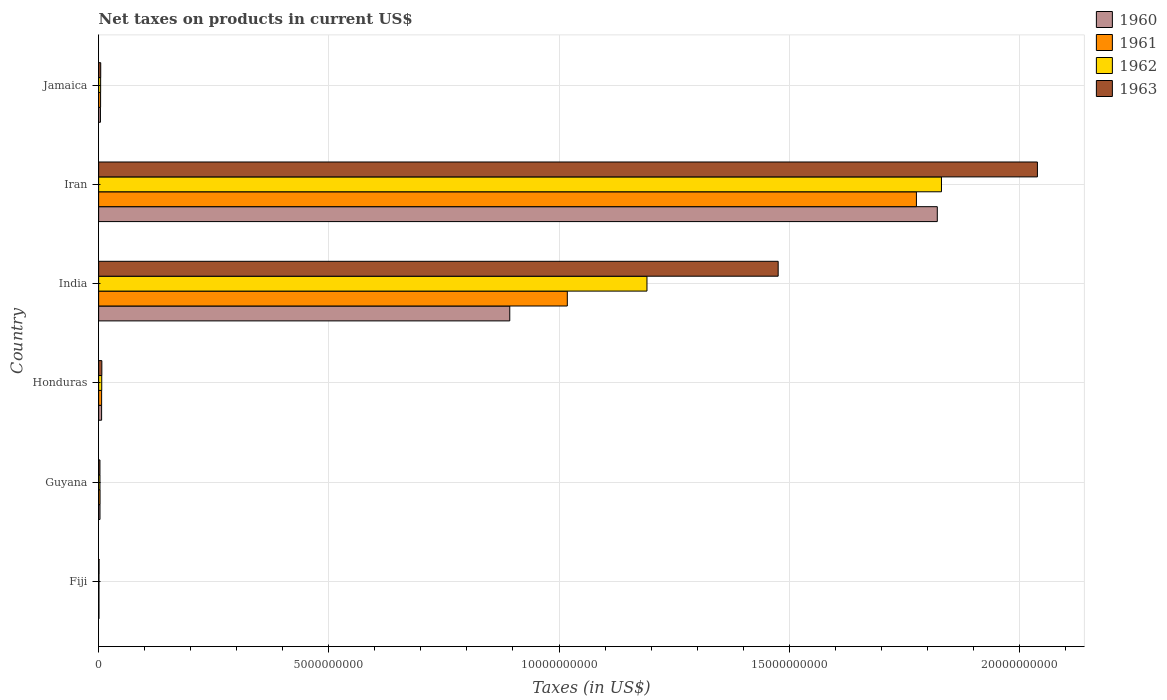How many different coloured bars are there?
Make the answer very short. 4. How many groups of bars are there?
Ensure brevity in your answer.  6. Are the number of bars per tick equal to the number of legend labels?
Offer a very short reply. Yes. What is the label of the 1st group of bars from the top?
Keep it short and to the point. Jamaica. What is the net taxes on products in 1962 in Fiji?
Ensure brevity in your answer.  7.40e+06. Across all countries, what is the maximum net taxes on products in 1963?
Ensure brevity in your answer.  2.04e+1. Across all countries, what is the minimum net taxes on products in 1963?
Provide a succinct answer. 8.90e+06. In which country was the net taxes on products in 1960 maximum?
Make the answer very short. Iran. In which country was the net taxes on products in 1960 minimum?
Offer a very short reply. Fiji. What is the total net taxes on products in 1960 in the graph?
Your response must be concise. 2.73e+1. What is the difference between the net taxes on products in 1961 in Honduras and that in India?
Offer a very short reply. -1.01e+1. What is the difference between the net taxes on products in 1963 in Jamaica and the net taxes on products in 1961 in Honduras?
Keep it short and to the point. -1.96e+07. What is the average net taxes on products in 1962 per country?
Provide a succinct answer. 5.06e+09. What is the difference between the net taxes on products in 1963 and net taxes on products in 1962 in Guyana?
Provide a succinct answer. -8.00e+05. What is the ratio of the net taxes on products in 1963 in Guyana to that in Jamaica?
Your answer should be compact. 0.62. Is the net taxes on products in 1962 in Iran less than that in Jamaica?
Offer a terse response. No. Is the difference between the net taxes on products in 1963 in Fiji and Honduras greater than the difference between the net taxes on products in 1962 in Fiji and Honduras?
Give a very brief answer. No. What is the difference between the highest and the second highest net taxes on products in 1962?
Keep it short and to the point. 6.40e+09. What is the difference between the highest and the lowest net taxes on products in 1963?
Offer a very short reply. 2.04e+1. Is it the case that in every country, the sum of the net taxes on products in 1962 and net taxes on products in 1960 is greater than the sum of net taxes on products in 1963 and net taxes on products in 1961?
Your response must be concise. No. What does the 2nd bar from the top in Guyana represents?
Make the answer very short. 1962. Are all the bars in the graph horizontal?
Your response must be concise. Yes. What is the difference between two consecutive major ticks on the X-axis?
Make the answer very short. 5.00e+09. Does the graph contain any zero values?
Make the answer very short. No. Does the graph contain grids?
Your answer should be very brief. Yes. What is the title of the graph?
Offer a terse response. Net taxes on products in current US$. Does "1964" appear as one of the legend labels in the graph?
Ensure brevity in your answer.  No. What is the label or title of the X-axis?
Provide a short and direct response. Taxes (in US$). What is the label or title of the Y-axis?
Provide a succinct answer. Country. What is the Taxes (in US$) of 1960 in Fiji?
Your answer should be very brief. 6.80e+06. What is the Taxes (in US$) in 1961 in Fiji?
Your response must be concise. 6.80e+06. What is the Taxes (in US$) of 1962 in Fiji?
Your response must be concise. 7.40e+06. What is the Taxes (in US$) in 1963 in Fiji?
Provide a succinct answer. 8.90e+06. What is the Taxes (in US$) in 1960 in Guyana?
Offer a terse response. 2.94e+07. What is the Taxes (in US$) of 1961 in Guyana?
Give a very brief answer. 3.07e+07. What is the Taxes (in US$) in 1962 in Guyana?
Give a very brief answer. 2.90e+07. What is the Taxes (in US$) in 1963 in Guyana?
Offer a terse response. 2.82e+07. What is the Taxes (in US$) in 1960 in Honduras?
Ensure brevity in your answer.  6.45e+07. What is the Taxes (in US$) in 1961 in Honduras?
Your response must be concise. 6.50e+07. What is the Taxes (in US$) of 1962 in Honduras?
Your response must be concise. 6.73e+07. What is the Taxes (in US$) in 1963 in Honduras?
Keep it short and to the point. 6.96e+07. What is the Taxes (in US$) of 1960 in India?
Give a very brief answer. 8.93e+09. What is the Taxes (in US$) in 1961 in India?
Provide a short and direct response. 1.02e+1. What is the Taxes (in US$) in 1962 in India?
Your response must be concise. 1.19e+1. What is the Taxes (in US$) in 1963 in India?
Make the answer very short. 1.48e+1. What is the Taxes (in US$) in 1960 in Iran?
Provide a succinct answer. 1.82e+1. What is the Taxes (in US$) in 1961 in Iran?
Ensure brevity in your answer.  1.78e+1. What is the Taxes (in US$) of 1962 in Iran?
Provide a short and direct response. 1.83e+1. What is the Taxes (in US$) of 1963 in Iran?
Offer a very short reply. 2.04e+1. What is the Taxes (in US$) of 1960 in Jamaica?
Provide a short and direct response. 3.93e+07. What is the Taxes (in US$) in 1961 in Jamaica?
Offer a very short reply. 4.26e+07. What is the Taxes (in US$) of 1962 in Jamaica?
Offer a terse response. 4.35e+07. What is the Taxes (in US$) in 1963 in Jamaica?
Make the answer very short. 4.54e+07. Across all countries, what is the maximum Taxes (in US$) of 1960?
Your answer should be very brief. 1.82e+1. Across all countries, what is the maximum Taxes (in US$) of 1961?
Offer a very short reply. 1.78e+1. Across all countries, what is the maximum Taxes (in US$) in 1962?
Your answer should be compact. 1.83e+1. Across all countries, what is the maximum Taxes (in US$) of 1963?
Your answer should be very brief. 2.04e+1. Across all countries, what is the minimum Taxes (in US$) of 1960?
Your response must be concise. 6.80e+06. Across all countries, what is the minimum Taxes (in US$) of 1961?
Keep it short and to the point. 6.80e+06. Across all countries, what is the minimum Taxes (in US$) in 1962?
Offer a very short reply. 7.40e+06. Across all countries, what is the minimum Taxes (in US$) of 1963?
Give a very brief answer. 8.90e+06. What is the total Taxes (in US$) of 1960 in the graph?
Your answer should be compact. 2.73e+1. What is the total Taxes (in US$) of 1961 in the graph?
Offer a terse response. 2.81e+1. What is the total Taxes (in US$) in 1962 in the graph?
Keep it short and to the point. 3.04e+1. What is the total Taxes (in US$) of 1963 in the graph?
Provide a succinct answer. 3.53e+1. What is the difference between the Taxes (in US$) of 1960 in Fiji and that in Guyana?
Make the answer very short. -2.26e+07. What is the difference between the Taxes (in US$) of 1961 in Fiji and that in Guyana?
Offer a terse response. -2.39e+07. What is the difference between the Taxes (in US$) in 1962 in Fiji and that in Guyana?
Provide a short and direct response. -2.16e+07. What is the difference between the Taxes (in US$) of 1963 in Fiji and that in Guyana?
Ensure brevity in your answer.  -1.93e+07. What is the difference between the Taxes (in US$) in 1960 in Fiji and that in Honduras?
Give a very brief answer. -5.77e+07. What is the difference between the Taxes (in US$) in 1961 in Fiji and that in Honduras?
Provide a short and direct response. -5.82e+07. What is the difference between the Taxes (in US$) in 1962 in Fiji and that in Honduras?
Your answer should be very brief. -5.99e+07. What is the difference between the Taxes (in US$) in 1963 in Fiji and that in Honduras?
Your answer should be very brief. -6.07e+07. What is the difference between the Taxes (in US$) of 1960 in Fiji and that in India?
Make the answer very short. -8.92e+09. What is the difference between the Taxes (in US$) of 1961 in Fiji and that in India?
Your response must be concise. -1.02e+1. What is the difference between the Taxes (in US$) in 1962 in Fiji and that in India?
Your answer should be very brief. -1.19e+1. What is the difference between the Taxes (in US$) of 1963 in Fiji and that in India?
Ensure brevity in your answer.  -1.48e+1. What is the difference between the Taxes (in US$) in 1960 in Fiji and that in Iran?
Your answer should be compact. -1.82e+1. What is the difference between the Taxes (in US$) in 1961 in Fiji and that in Iran?
Make the answer very short. -1.78e+1. What is the difference between the Taxes (in US$) in 1962 in Fiji and that in Iran?
Your response must be concise. -1.83e+1. What is the difference between the Taxes (in US$) in 1963 in Fiji and that in Iran?
Your answer should be compact. -2.04e+1. What is the difference between the Taxes (in US$) of 1960 in Fiji and that in Jamaica?
Make the answer very short. -3.25e+07. What is the difference between the Taxes (in US$) of 1961 in Fiji and that in Jamaica?
Make the answer very short. -3.58e+07. What is the difference between the Taxes (in US$) of 1962 in Fiji and that in Jamaica?
Offer a very short reply. -3.61e+07. What is the difference between the Taxes (in US$) of 1963 in Fiji and that in Jamaica?
Provide a short and direct response. -3.65e+07. What is the difference between the Taxes (in US$) of 1960 in Guyana and that in Honduras?
Provide a succinct answer. -3.51e+07. What is the difference between the Taxes (in US$) of 1961 in Guyana and that in Honduras?
Offer a terse response. -3.43e+07. What is the difference between the Taxes (in US$) of 1962 in Guyana and that in Honduras?
Offer a terse response. -3.83e+07. What is the difference between the Taxes (in US$) in 1963 in Guyana and that in Honduras?
Your answer should be compact. -4.14e+07. What is the difference between the Taxes (in US$) of 1960 in Guyana and that in India?
Offer a terse response. -8.90e+09. What is the difference between the Taxes (in US$) in 1961 in Guyana and that in India?
Keep it short and to the point. -1.01e+1. What is the difference between the Taxes (in US$) of 1962 in Guyana and that in India?
Give a very brief answer. -1.19e+1. What is the difference between the Taxes (in US$) of 1963 in Guyana and that in India?
Ensure brevity in your answer.  -1.47e+1. What is the difference between the Taxes (in US$) in 1960 in Guyana and that in Iran?
Offer a terse response. -1.82e+1. What is the difference between the Taxes (in US$) in 1961 in Guyana and that in Iran?
Keep it short and to the point. -1.77e+1. What is the difference between the Taxes (in US$) of 1962 in Guyana and that in Iran?
Offer a terse response. -1.83e+1. What is the difference between the Taxes (in US$) of 1963 in Guyana and that in Iran?
Ensure brevity in your answer.  -2.04e+1. What is the difference between the Taxes (in US$) of 1960 in Guyana and that in Jamaica?
Make the answer very short. -9.90e+06. What is the difference between the Taxes (in US$) of 1961 in Guyana and that in Jamaica?
Your answer should be very brief. -1.19e+07. What is the difference between the Taxes (in US$) of 1962 in Guyana and that in Jamaica?
Provide a short and direct response. -1.45e+07. What is the difference between the Taxes (in US$) in 1963 in Guyana and that in Jamaica?
Give a very brief answer. -1.72e+07. What is the difference between the Taxes (in US$) of 1960 in Honduras and that in India?
Offer a very short reply. -8.87e+09. What is the difference between the Taxes (in US$) in 1961 in Honduras and that in India?
Keep it short and to the point. -1.01e+1. What is the difference between the Taxes (in US$) of 1962 in Honduras and that in India?
Keep it short and to the point. -1.18e+1. What is the difference between the Taxes (in US$) in 1963 in Honduras and that in India?
Your answer should be very brief. -1.47e+1. What is the difference between the Taxes (in US$) of 1960 in Honduras and that in Iran?
Your answer should be compact. -1.82e+1. What is the difference between the Taxes (in US$) of 1961 in Honduras and that in Iran?
Your answer should be compact. -1.77e+1. What is the difference between the Taxes (in US$) of 1962 in Honduras and that in Iran?
Ensure brevity in your answer.  -1.82e+1. What is the difference between the Taxes (in US$) in 1963 in Honduras and that in Iran?
Make the answer very short. -2.03e+1. What is the difference between the Taxes (in US$) of 1960 in Honduras and that in Jamaica?
Provide a succinct answer. 2.52e+07. What is the difference between the Taxes (in US$) in 1961 in Honduras and that in Jamaica?
Offer a terse response. 2.24e+07. What is the difference between the Taxes (in US$) in 1962 in Honduras and that in Jamaica?
Keep it short and to the point. 2.38e+07. What is the difference between the Taxes (in US$) in 1963 in Honduras and that in Jamaica?
Offer a terse response. 2.42e+07. What is the difference between the Taxes (in US$) in 1960 in India and that in Iran?
Your response must be concise. -9.29e+09. What is the difference between the Taxes (in US$) in 1961 in India and that in Iran?
Make the answer very short. -7.58e+09. What is the difference between the Taxes (in US$) of 1962 in India and that in Iran?
Your answer should be very brief. -6.40e+09. What is the difference between the Taxes (in US$) in 1963 in India and that in Iran?
Offer a very short reply. -5.63e+09. What is the difference between the Taxes (in US$) of 1960 in India and that in Jamaica?
Keep it short and to the point. 8.89e+09. What is the difference between the Taxes (in US$) in 1961 in India and that in Jamaica?
Give a very brief answer. 1.01e+1. What is the difference between the Taxes (in US$) of 1962 in India and that in Jamaica?
Ensure brevity in your answer.  1.19e+1. What is the difference between the Taxes (in US$) in 1963 in India and that in Jamaica?
Your answer should be very brief. 1.47e+1. What is the difference between the Taxes (in US$) of 1960 in Iran and that in Jamaica?
Provide a short and direct response. 1.82e+1. What is the difference between the Taxes (in US$) of 1961 in Iran and that in Jamaica?
Keep it short and to the point. 1.77e+1. What is the difference between the Taxes (in US$) in 1962 in Iran and that in Jamaica?
Make the answer very short. 1.83e+1. What is the difference between the Taxes (in US$) in 1963 in Iran and that in Jamaica?
Make the answer very short. 2.03e+1. What is the difference between the Taxes (in US$) in 1960 in Fiji and the Taxes (in US$) in 1961 in Guyana?
Your answer should be compact. -2.39e+07. What is the difference between the Taxes (in US$) in 1960 in Fiji and the Taxes (in US$) in 1962 in Guyana?
Your answer should be compact. -2.22e+07. What is the difference between the Taxes (in US$) of 1960 in Fiji and the Taxes (in US$) of 1963 in Guyana?
Your response must be concise. -2.14e+07. What is the difference between the Taxes (in US$) in 1961 in Fiji and the Taxes (in US$) in 1962 in Guyana?
Make the answer very short. -2.22e+07. What is the difference between the Taxes (in US$) of 1961 in Fiji and the Taxes (in US$) of 1963 in Guyana?
Your answer should be compact. -2.14e+07. What is the difference between the Taxes (in US$) in 1962 in Fiji and the Taxes (in US$) in 1963 in Guyana?
Offer a very short reply. -2.08e+07. What is the difference between the Taxes (in US$) of 1960 in Fiji and the Taxes (in US$) of 1961 in Honduras?
Offer a very short reply. -5.82e+07. What is the difference between the Taxes (in US$) in 1960 in Fiji and the Taxes (in US$) in 1962 in Honduras?
Give a very brief answer. -6.05e+07. What is the difference between the Taxes (in US$) of 1960 in Fiji and the Taxes (in US$) of 1963 in Honduras?
Your answer should be compact. -6.28e+07. What is the difference between the Taxes (in US$) of 1961 in Fiji and the Taxes (in US$) of 1962 in Honduras?
Provide a succinct answer. -6.05e+07. What is the difference between the Taxes (in US$) in 1961 in Fiji and the Taxes (in US$) in 1963 in Honduras?
Offer a terse response. -6.28e+07. What is the difference between the Taxes (in US$) of 1962 in Fiji and the Taxes (in US$) of 1963 in Honduras?
Keep it short and to the point. -6.22e+07. What is the difference between the Taxes (in US$) in 1960 in Fiji and the Taxes (in US$) in 1961 in India?
Your answer should be very brief. -1.02e+1. What is the difference between the Taxes (in US$) of 1960 in Fiji and the Taxes (in US$) of 1962 in India?
Provide a short and direct response. -1.19e+1. What is the difference between the Taxes (in US$) in 1960 in Fiji and the Taxes (in US$) in 1963 in India?
Offer a very short reply. -1.48e+1. What is the difference between the Taxes (in US$) in 1961 in Fiji and the Taxes (in US$) in 1962 in India?
Provide a short and direct response. -1.19e+1. What is the difference between the Taxes (in US$) in 1961 in Fiji and the Taxes (in US$) in 1963 in India?
Provide a succinct answer. -1.48e+1. What is the difference between the Taxes (in US$) of 1962 in Fiji and the Taxes (in US$) of 1963 in India?
Provide a succinct answer. -1.48e+1. What is the difference between the Taxes (in US$) in 1960 in Fiji and the Taxes (in US$) in 1961 in Iran?
Your answer should be compact. -1.78e+1. What is the difference between the Taxes (in US$) of 1960 in Fiji and the Taxes (in US$) of 1962 in Iran?
Give a very brief answer. -1.83e+1. What is the difference between the Taxes (in US$) in 1960 in Fiji and the Taxes (in US$) in 1963 in Iran?
Your response must be concise. -2.04e+1. What is the difference between the Taxes (in US$) in 1961 in Fiji and the Taxes (in US$) in 1962 in Iran?
Keep it short and to the point. -1.83e+1. What is the difference between the Taxes (in US$) of 1961 in Fiji and the Taxes (in US$) of 1963 in Iran?
Give a very brief answer. -2.04e+1. What is the difference between the Taxes (in US$) in 1962 in Fiji and the Taxes (in US$) in 1963 in Iran?
Your answer should be very brief. -2.04e+1. What is the difference between the Taxes (in US$) of 1960 in Fiji and the Taxes (in US$) of 1961 in Jamaica?
Your response must be concise. -3.58e+07. What is the difference between the Taxes (in US$) of 1960 in Fiji and the Taxes (in US$) of 1962 in Jamaica?
Your response must be concise. -3.67e+07. What is the difference between the Taxes (in US$) in 1960 in Fiji and the Taxes (in US$) in 1963 in Jamaica?
Provide a short and direct response. -3.86e+07. What is the difference between the Taxes (in US$) in 1961 in Fiji and the Taxes (in US$) in 1962 in Jamaica?
Provide a short and direct response. -3.67e+07. What is the difference between the Taxes (in US$) in 1961 in Fiji and the Taxes (in US$) in 1963 in Jamaica?
Your answer should be compact. -3.86e+07. What is the difference between the Taxes (in US$) in 1962 in Fiji and the Taxes (in US$) in 1963 in Jamaica?
Your answer should be compact. -3.80e+07. What is the difference between the Taxes (in US$) in 1960 in Guyana and the Taxes (in US$) in 1961 in Honduras?
Offer a very short reply. -3.56e+07. What is the difference between the Taxes (in US$) of 1960 in Guyana and the Taxes (in US$) of 1962 in Honduras?
Offer a very short reply. -3.79e+07. What is the difference between the Taxes (in US$) in 1960 in Guyana and the Taxes (in US$) in 1963 in Honduras?
Provide a succinct answer. -4.02e+07. What is the difference between the Taxes (in US$) in 1961 in Guyana and the Taxes (in US$) in 1962 in Honduras?
Provide a succinct answer. -3.66e+07. What is the difference between the Taxes (in US$) in 1961 in Guyana and the Taxes (in US$) in 1963 in Honduras?
Your response must be concise. -3.89e+07. What is the difference between the Taxes (in US$) in 1962 in Guyana and the Taxes (in US$) in 1963 in Honduras?
Your response must be concise. -4.06e+07. What is the difference between the Taxes (in US$) of 1960 in Guyana and the Taxes (in US$) of 1961 in India?
Offer a very short reply. -1.02e+1. What is the difference between the Taxes (in US$) of 1960 in Guyana and the Taxes (in US$) of 1962 in India?
Give a very brief answer. -1.19e+1. What is the difference between the Taxes (in US$) of 1960 in Guyana and the Taxes (in US$) of 1963 in India?
Offer a very short reply. -1.47e+1. What is the difference between the Taxes (in US$) in 1961 in Guyana and the Taxes (in US$) in 1962 in India?
Your answer should be very brief. -1.19e+1. What is the difference between the Taxes (in US$) in 1961 in Guyana and the Taxes (in US$) in 1963 in India?
Ensure brevity in your answer.  -1.47e+1. What is the difference between the Taxes (in US$) in 1962 in Guyana and the Taxes (in US$) in 1963 in India?
Give a very brief answer. -1.47e+1. What is the difference between the Taxes (in US$) in 1960 in Guyana and the Taxes (in US$) in 1961 in Iran?
Provide a succinct answer. -1.77e+1. What is the difference between the Taxes (in US$) in 1960 in Guyana and the Taxes (in US$) in 1962 in Iran?
Give a very brief answer. -1.83e+1. What is the difference between the Taxes (in US$) in 1960 in Guyana and the Taxes (in US$) in 1963 in Iran?
Keep it short and to the point. -2.04e+1. What is the difference between the Taxes (in US$) in 1961 in Guyana and the Taxes (in US$) in 1962 in Iran?
Keep it short and to the point. -1.83e+1. What is the difference between the Taxes (in US$) in 1961 in Guyana and the Taxes (in US$) in 1963 in Iran?
Give a very brief answer. -2.04e+1. What is the difference between the Taxes (in US$) of 1962 in Guyana and the Taxes (in US$) of 1963 in Iran?
Your answer should be compact. -2.04e+1. What is the difference between the Taxes (in US$) in 1960 in Guyana and the Taxes (in US$) in 1961 in Jamaica?
Give a very brief answer. -1.32e+07. What is the difference between the Taxes (in US$) of 1960 in Guyana and the Taxes (in US$) of 1962 in Jamaica?
Offer a terse response. -1.41e+07. What is the difference between the Taxes (in US$) in 1960 in Guyana and the Taxes (in US$) in 1963 in Jamaica?
Make the answer very short. -1.60e+07. What is the difference between the Taxes (in US$) of 1961 in Guyana and the Taxes (in US$) of 1962 in Jamaica?
Give a very brief answer. -1.28e+07. What is the difference between the Taxes (in US$) of 1961 in Guyana and the Taxes (in US$) of 1963 in Jamaica?
Your answer should be compact. -1.47e+07. What is the difference between the Taxes (in US$) of 1962 in Guyana and the Taxes (in US$) of 1963 in Jamaica?
Keep it short and to the point. -1.64e+07. What is the difference between the Taxes (in US$) in 1960 in Honduras and the Taxes (in US$) in 1961 in India?
Make the answer very short. -1.01e+1. What is the difference between the Taxes (in US$) of 1960 in Honduras and the Taxes (in US$) of 1962 in India?
Offer a terse response. -1.18e+1. What is the difference between the Taxes (in US$) of 1960 in Honduras and the Taxes (in US$) of 1963 in India?
Your answer should be very brief. -1.47e+1. What is the difference between the Taxes (in US$) of 1961 in Honduras and the Taxes (in US$) of 1962 in India?
Make the answer very short. -1.18e+1. What is the difference between the Taxes (in US$) of 1961 in Honduras and the Taxes (in US$) of 1963 in India?
Give a very brief answer. -1.47e+1. What is the difference between the Taxes (in US$) in 1962 in Honduras and the Taxes (in US$) in 1963 in India?
Give a very brief answer. -1.47e+1. What is the difference between the Taxes (in US$) of 1960 in Honduras and the Taxes (in US$) of 1961 in Iran?
Your response must be concise. -1.77e+1. What is the difference between the Taxes (in US$) in 1960 in Honduras and the Taxes (in US$) in 1962 in Iran?
Offer a very short reply. -1.82e+1. What is the difference between the Taxes (in US$) in 1960 in Honduras and the Taxes (in US$) in 1963 in Iran?
Keep it short and to the point. -2.03e+1. What is the difference between the Taxes (in US$) of 1961 in Honduras and the Taxes (in US$) of 1962 in Iran?
Keep it short and to the point. -1.82e+1. What is the difference between the Taxes (in US$) of 1961 in Honduras and the Taxes (in US$) of 1963 in Iran?
Ensure brevity in your answer.  -2.03e+1. What is the difference between the Taxes (in US$) in 1962 in Honduras and the Taxes (in US$) in 1963 in Iran?
Make the answer very short. -2.03e+1. What is the difference between the Taxes (in US$) of 1960 in Honduras and the Taxes (in US$) of 1961 in Jamaica?
Your answer should be compact. 2.19e+07. What is the difference between the Taxes (in US$) in 1960 in Honduras and the Taxes (in US$) in 1962 in Jamaica?
Ensure brevity in your answer.  2.10e+07. What is the difference between the Taxes (in US$) of 1960 in Honduras and the Taxes (in US$) of 1963 in Jamaica?
Make the answer very short. 1.91e+07. What is the difference between the Taxes (in US$) of 1961 in Honduras and the Taxes (in US$) of 1962 in Jamaica?
Offer a very short reply. 2.15e+07. What is the difference between the Taxes (in US$) of 1961 in Honduras and the Taxes (in US$) of 1963 in Jamaica?
Offer a terse response. 1.96e+07. What is the difference between the Taxes (in US$) in 1962 in Honduras and the Taxes (in US$) in 1963 in Jamaica?
Your answer should be very brief. 2.19e+07. What is the difference between the Taxes (in US$) in 1960 in India and the Taxes (in US$) in 1961 in Iran?
Keep it short and to the point. -8.83e+09. What is the difference between the Taxes (in US$) in 1960 in India and the Taxes (in US$) in 1962 in Iran?
Offer a very short reply. -9.38e+09. What is the difference between the Taxes (in US$) in 1960 in India and the Taxes (in US$) in 1963 in Iran?
Make the answer very short. -1.15e+1. What is the difference between the Taxes (in US$) in 1961 in India and the Taxes (in US$) in 1962 in Iran?
Give a very brief answer. -8.13e+09. What is the difference between the Taxes (in US$) in 1961 in India and the Taxes (in US$) in 1963 in Iran?
Offer a terse response. -1.02e+1. What is the difference between the Taxes (in US$) in 1962 in India and the Taxes (in US$) in 1963 in Iran?
Make the answer very short. -8.48e+09. What is the difference between the Taxes (in US$) of 1960 in India and the Taxes (in US$) of 1961 in Jamaica?
Your answer should be compact. 8.89e+09. What is the difference between the Taxes (in US$) of 1960 in India and the Taxes (in US$) of 1962 in Jamaica?
Offer a terse response. 8.89e+09. What is the difference between the Taxes (in US$) of 1960 in India and the Taxes (in US$) of 1963 in Jamaica?
Offer a terse response. 8.88e+09. What is the difference between the Taxes (in US$) of 1961 in India and the Taxes (in US$) of 1962 in Jamaica?
Make the answer very short. 1.01e+1. What is the difference between the Taxes (in US$) of 1961 in India and the Taxes (in US$) of 1963 in Jamaica?
Offer a terse response. 1.01e+1. What is the difference between the Taxes (in US$) of 1962 in India and the Taxes (in US$) of 1963 in Jamaica?
Your answer should be very brief. 1.19e+1. What is the difference between the Taxes (in US$) of 1960 in Iran and the Taxes (in US$) of 1961 in Jamaica?
Keep it short and to the point. 1.82e+1. What is the difference between the Taxes (in US$) in 1960 in Iran and the Taxes (in US$) in 1962 in Jamaica?
Offer a terse response. 1.82e+1. What is the difference between the Taxes (in US$) in 1960 in Iran and the Taxes (in US$) in 1963 in Jamaica?
Your answer should be very brief. 1.82e+1. What is the difference between the Taxes (in US$) of 1961 in Iran and the Taxes (in US$) of 1962 in Jamaica?
Your answer should be compact. 1.77e+1. What is the difference between the Taxes (in US$) in 1961 in Iran and the Taxes (in US$) in 1963 in Jamaica?
Your answer should be very brief. 1.77e+1. What is the difference between the Taxes (in US$) of 1962 in Iran and the Taxes (in US$) of 1963 in Jamaica?
Offer a very short reply. 1.83e+1. What is the average Taxes (in US$) of 1960 per country?
Offer a very short reply. 4.55e+09. What is the average Taxes (in US$) of 1961 per country?
Provide a short and direct response. 4.68e+09. What is the average Taxes (in US$) of 1962 per country?
Give a very brief answer. 5.06e+09. What is the average Taxes (in US$) in 1963 per country?
Provide a succinct answer. 5.88e+09. What is the difference between the Taxes (in US$) of 1960 and Taxes (in US$) of 1961 in Fiji?
Your answer should be very brief. 0. What is the difference between the Taxes (in US$) of 1960 and Taxes (in US$) of 1962 in Fiji?
Your answer should be very brief. -6.00e+05. What is the difference between the Taxes (in US$) of 1960 and Taxes (in US$) of 1963 in Fiji?
Your response must be concise. -2.10e+06. What is the difference between the Taxes (in US$) in 1961 and Taxes (in US$) in 1962 in Fiji?
Offer a very short reply. -6.00e+05. What is the difference between the Taxes (in US$) in 1961 and Taxes (in US$) in 1963 in Fiji?
Provide a short and direct response. -2.10e+06. What is the difference between the Taxes (in US$) of 1962 and Taxes (in US$) of 1963 in Fiji?
Give a very brief answer. -1.50e+06. What is the difference between the Taxes (in US$) of 1960 and Taxes (in US$) of 1961 in Guyana?
Your response must be concise. -1.30e+06. What is the difference between the Taxes (in US$) of 1960 and Taxes (in US$) of 1962 in Guyana?
Make the answer very short. 4.00e+05. What is the difference between the Taxes (in US$) in 1960 and Taxes (in US$) in 1963 in Guyana?
Offer a very short reply. 1.20e+06. What is the difference between the Taxes (in US$) of 1961 and Taxes (in US$) of 1962 in Guyana?
Your response must be concise. 1.70e+06. What is the difference between the Taxes (in US$) in 1961 and Taxes (in US$) in 1963 in Guyana?
Provide a succinct answer. 2.50e+06. What is the difference between the Taxes (in US$) of 1960 and Taxes (in US$) of 1961 in Honduras?
Your answer should be very brief. -5.00e+05. What is the difference between the Taxes (in US$) of 1960 and Taxes (in US$) of 1962 in Honduras?
Offer a terse response. -2.80e+06. What is the difference between the Taxes (in US$) in 1960 and Taxes (in US$) in 1963 in Honduras?
Ensure brevity in your answer.  -5.10e+06. What is the difference between the Taxes (in US$) of 1961 and Taxes (in US$) of 1962 in Honduras?
Ensure brevity in your answer.  -2.30e+06. What is the difference between the Taxes (in US$) of 1961 and Taxes (in US$) of 1963 in Honduras?
Keep it short and to the point. -4.60e+06. What is the difference between the Taxes (in US$) of 1962 and Taxes (in US$) of 1963 in Honduras?
Your response must be concise. -2.30e+06. What is the difference between the Taxes (in US$) of 1960 and Taxes (in US$) of 1961 in India?
Give a very brief answer. -1.25e+09. What is the difference between the Taxes (in US$) of 1960 and Taxes (in US$) of 1962 in India?
Offer a terse response. -2.98e+09. What is the difference between the Taxes (in US$) of 1960 and Taxes (in US$) of 1963 in India?
Make the answer very short. -5.83e+09. What is the difference between the Taxes (in US$) in 1961 and Taxes (in US$) in 1962 in India?
Give a very brief answer. -1.73e+09. What is the difference between the Taxes (in US$) of 1961 and Taxes (in US$) of 1963 in India?
Offer a terse response. -4.58e+09. What is the difference between the Taxes (in US$) in 1962 and Taxes (in US$) in 1963 in India?
Give a very brief answer. -2.85e+09. What is the difference between the Taxes (in US$) of 1960 and Taxes (in US$) of 1961 in Iran?
Provide a short and direct response. 4.53e+08. What is the difference between the Taxes (in US$) in 1960 and Taxes (in US$) in 1962 in Iran?
Provide a short and direct response. -9.06e+07. What is the difference between the Taxes (in US$) in 1960 and Taxes (in US$) in 1963 in Iran?
Ensure brevity in your answer.  -2.18e+09. What is the difference between the Taxes (in US$) of 1961 and Taxes (in US$) of 1962 in Iran?
Make the answer very short. -5.44e+08. What is the difference between the Taxes (in US$) in 1961 and Taxes (in US$) in 1963 in Iran?
Ensure brevity in your answer.  -2.63e+09. What is the difference between the Taxes (in US$) of 1962 and Taxes (in US$) of 1963 in Iran?
Your response must be concise. -2.08e+09. What is the difference between the Taxes (in US$) in 1960 and Taxes (in US$) in 1961 in Jamaica?
Provide a short and direct response. -3.30e+06. What is the difference between the Taxes (in US$) in 1960 and Taxes (in US$) in 1962 in Jamaica?
Ensure brevity in your answer.  -4.20e+06. What is the difference between the Taxes (in US$) of 1960 and Taxes (in US$) of 1963 in Jamaica?
Keep it short and to the point. -6.10e+06. What is the difference between the Taxes (in US$) of 1961 and Taxes (in US$) of 1962 in Jamaica?
Your answer should be very brief. -9.00e+05. What is the difference between the Taxes (in US$) of 1961 and Taxes (in US$) of 1963 in Jamaica?
Offer a very short reply. -2.80e+06. What is the difference between the Taxes (in US$) of 1962 and Taxes (in US$) of 1963 in Jamaica?
Your answer should be compact. -1.90e+06. What is the ratio of the Taxes (in US$) of 1960 in Fiji to that in Guyana?
Your answer should be compact. 0.23. What is the ratio of the Taxes (in US$) of 1961 in Fiji to that in Guyana?
Keep it short and to the point. 0.22. What is the ratio of the Taxes (in US$) of 1962 in Fiji to that in Guyana?
Your answer should be compact. 0.26. What is the ratio of the Taxes (in US$) of 1963 in Fiji to that in Guyana?
Make the answer very short. 0.32. What is the ratio of the Taxes (in US$) of 1960 in Fiji to that in Honduras?
Provide a short and direct response. 0.11. What is the ratio of the Taxes (in US$) of 1961 in Fiji to that in Honduras?
Give a very brief answer. 0.1. What is the ratio of the Taxes (in US$) of 1962 in Fiji to that in Honduras?
Give a very brief answer. 0.11. What is the ratio of the Taxes (in US$) of 1963 in Fiji to that in Honduras?
Your response must be concise. 0.13. What is the ratio of the Taxes (in US$) in 1960 in Fiji to that in India?
Provide a short and direct response. 0. What is the ratio of the Taxes (in US$) in 1961 in Fiji to that in India?
Give a very brief answer. 0. What is the ratio of the Taxes (in US$) of 1962 in Fiji to that in India?
Make the answer very short. 0. What is the ratio of the Taxes (in US$) of 1963 in Fiji to that in India?
Your response must be concise. 0. What is the ratio of the Taxes (in US$) in 1960 in Fiji to that in Iran?
Your response must be concise. 0. What is the ratio of the Taxes (in US$) of 1963 in Fiji to that in Iran?
Ensure brevity in your answer.  0. What is the ratio of the Taxes (in US$) in 1960 in Fiji to that in Jamaica?
Ensure brevity in your answer.  0.17. What is the ratio of the Taxes (in US$) in 1961 in Fiji to that in Jamaica?
Offer a terse response. 0.16. What is the ratio of the Taxes (in US$) in 1962 in Fiji to that in Jamaica?
Your answer should be compact. 0.17. What is the ratio of the Taxes (in US$) of 1963 in Fiji to that in Jamaica?
Your answer should be compact. 0.2. What is the ratio of the Taxes (in US$) in 1960 in Guyana to that in Honduras?
Give a very brief answer. 0.46. What is the ratio of the Taxes (in US$) in 1961 in Guyana to that in Honduras?
Provide a succinct answer. 0.47. What is the ratio of the Taxes (in US$) of 1962 in Guyana to that in Honduras?
Offer a very short reply. 0.43. What is the ratio of the Taxes (in US$) in 1963 in Guyana to that in Honduras?
Your answer should be very brief. 0.41. What is the ratio of the Taxes (in US$) in 1960 in Guyana to that in India?
Provide a succinct answer. 0. What is the ratio of the Taxes (in US$) in 1961 in Guyana to that in India?
Keep it short and to the point. 0. What is the ratio of the Taxes (in US$) of 1962 in Guyana to that in India?
Keep it short and to the point. 0. What is the ratio of the Taxes (in US$) in 1963 in Guyana to that in India?
Give a very brief answer. 0. What is the ratio of the Taxes (in US$) in 1960 in Guyana to that in Iran?
Your answer should be very brief. 0. What is the ratio of the Taxes (in US$) in 1961 in Guyana to that in Iran?
Ensure brevity in your answer.  0. What is the ratio of the Taxes (in US$) in 1962 in Guyana to that in Iran?
Give a very brief answer. 0. What is the ratio of the Taxes (in US$) in 1963 in Guyana to that in Iran?
Your answer should be compact. 0. What is the ratio of the Taxes (in US$) in 1960 in Guyana to that in Jamaica?
Give a very brief answer. 0.75. What is the ratio of the Taxes (in US$) of 1961 in Guyana to that in Jamaica?
Provide a succinct answer. 0.72. What is the ratio of the Taxes (in US$) in 1963 in Guyana to that in Jamaica?
Make the answer very short. 0.62. What is the ratio of the Taxes (in US$) of 1960 in Honduras to that in India?
Offer a very short reply. 0.01. What is the ratio of the Taxes (in US$) in 1961 in Honduras to that in India?
Make the answer very short. 0.01. What is the ratio of the Taxes (in US$) of 1962 in Honduras to that in India?
Make the answer very short. 0.01. What is the ratio of the Taxes (in US$) of 1963 in Honduras to that in India?
Give a very brief answer. 0. What is the ratio of the Taxes (in US$) of 1960 in Honduras to that in Iran?
Offer a very short reply. 0. What is the ratio of the Taxes (in US$) in 1961 in Honduras to that in Iran?
Ensure brevity in your answer.  0. What is the ratio of the Taxes (in US$) of 1962 in Honduras to that in Iran?
Your answer should be very brief. 0. What is the ratio of the Taxes (in US$) of 1963 in Honduras to that in Iran?
Ensure brevity in your answer.  0. What is the ratio of the Taxes (in US$) of 1960 in Honduras to that in Jamaica?
Your answer should be compact. 1.64. What is the ratio of the Taxes (in US$) of 1961 in Honduras to that in Jamaica?
Provide a succinct answer. 1.53. What is the ratio of the Taxes (in US$) of 1962 in Honduras to that in Jamaica?
Your answer should be compact. 1.55. What is the ratio of the Taxes (in US$) of 1963 in Honduras to that in Jamaica?
Your response must be concise. 1.53. What is the ratio of the Taxes (in US$) in 1960 in India to that in Iran?
Your response must be concise. 0.49. What is the ratio of the Taxes (in US$) of 1961 in India to that in Iran?
Offer a very short reply. 0.57. What is the ratio of the Taxes (in US$) of 1962 in India to that in Iran?
Keep it short and to the point. 0.65. What is the ratio of the Taxes (in US$) of 1963 in India to that in Iran?
Make the answer very short. 0.72. What is the ratio of the Taxes (in US$) of 1960 in India to that in Jamaica?
Offer a terse response. 227.23. What is the ratio of the Taxes (in US$) in 1961 in India to that in Jamaica?
Ensure brevity in your answer.  238.97. What is the ratio of the Taxes (in US$) of 1962 in India to that in Jamaica?
Your response must be concise. 273.79. What is the ratio of the Taxes (in US$) of 1963 in India to that in Jamaica?
Your answer should be compact. 325.11. What is the ratio of the Taxes (in US$) of 1960 in Iran to that in Jamaica?
Give a very brief answer. 463.51. What is the ratio of the Taxes (in US$) of 1961 in Iran to that in Jamaica?
Keep it short and to the point. 416.97. What is the ratio of the Taxes (in US$) of 1962 in Iran to that in Jamaica?
Provide a succinct answer. 420.84. What is the ratio of the Taxes (in US$) of 1963 in Iran to that in Jamaica?
Your answer should be very brief. 449.14. What is the difference between the highest and the second highest Taxes (in US$) of 1960?
Make the answer very short. 9.29e+09. What is the difference between the highest and the second highest Taxes (in US$) in 1961?
Keep it short and to the point. 7.58e+09. What is the difference between the highest and the second highest Taxes (in US$) of 1962?
Give a very brief answer. 6.40e+09. What is the difference between the highest and the second highest Taxes (in US$) of 1963?
Provide a short and direct response. 5.63e+09. What is the difference between the highest and the lowest Taxes (in US$) of 1960?
Give a very brief answer. 1.82e+1. What is the difference between the highest and the lowest Taxes (in US$) in 1961?
Your answer should be compact. 1.78e+1. What is the difference between the highest and the lowest Taxes (in US$) of 1962?
Keep it short and to the point. 1.83e+1. What is the difference between the highest and the lowest Taxes (in US$) in 1963?
Provide a short and direct response. 2.04e+1. 